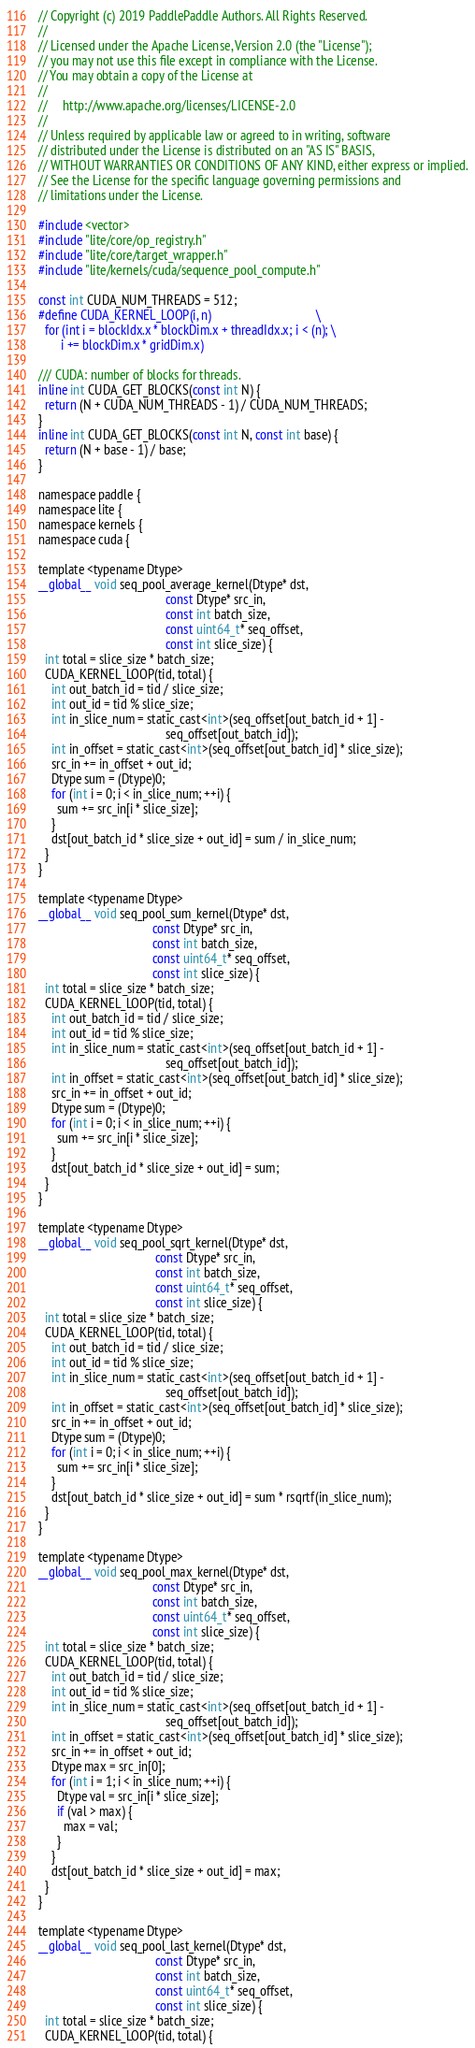<code> <loc_0><loc_0><loc_500><loc_500><_Cuda_>// Copyright (c) 2019 PaddlePaddle Authors. All Rights Reserved.
//
// Licensed under the Apache License, Version 2.0 (the "License");
// you may not use this file except in compliance with the License.
// You may obtain a copy of the License at
//
//     http://www.apache.org/licenses/LICENSE-2.0
//
// Unless required by applicable law or agreed to in writing, software
// distributed under the License is distributed on an "AS IS" BASIS,
// WITHOUT WARRANTIES OR CONDITIONS OF ANY KIND, either express or implied.
// See the License for the specific language governing permissions and
// limitations under the License.

#include <vector>
#include "lite/core/op_registry.h"
#include "lite/core/target_wrapper.h"
#include "lite/kernels/cuda/sequence_pool_compute.h"

const int CUDA_NUM_THREADS = 512;
#define CUDA_KERNEL_LOOP(i, n)                                 \
  for (int i = blockIdx.x * blockDim.x + threadIdx.x; i < (n); \
       i += blockDim.x * gridDim.x)

/// CUDA: number of blocks for threads.
inline int CUDA_GET_BLOCKS(const int N) {
  return (N + CUDA_NUM_THREADS - 1) / CUDA_NUM_THREADS;
}
inline int CUDA_GET_BLOCKS(const int N, const int base) {
  return (N + base - 1) / base;
}

namespace paddle {
namespace lite {
namespace kernels {
namespace cuda {

template <typename Dtype>
__global__ void seq_pool_average_kernel(Dtype* dst,
                                        const Dtype* src_in,
                                        const int batch_size,
                                        const uint64_t* seq_offset,
                                        const int slice_size) {
  int total = slice_size * batch_size;
  CUDA_KERNEL_LOOP(tid, total) {
    int out_batch_id = tid / slice_size;
    int out_id = tid % slice_size;
    int in_slice_num = static_cast<int>(seq_offset[out_batch_id + 1] -
                                        seq_offset[out_batch_id]);
    int in_offset = static_cast<int>(seq_offset[out_batch_id] * slice_size);
    src_in += in_offset + out_id;
    Dtype sum = (Dtype)0;
    for (int i = 0; i < in_slice_num; ++i) {
      sum += src_in[i * slice_size];
    }
    dst[out_batch_id * slice_size + out_id] = sum / in_slice_num;
  }
}

template <typename Dtype>
__global__ void seq_pool_sum_kernel(Dtype* dst,
                                    const Dtype* src_in,
                                    const int batch_size,
                                    const uint64_t* seq_offset,
                                    const int slice_size) {
  int total = slice_size * batch_size;
  CUDA_KERNEL_LOOP(tid, total) {
    int out_batch_id = tid / slice_size;
    int out_id = tid % slice_size;
    int in_slice_num = static_cast<int>(seq_offset[out_batch_id + 1] -
                                        seq_offset[out_batch_id]);
    int in_offset = static_cast<int>(seq_offset[out_batch_id] * slice_size);
    src_in += in_offset + out_id;
    Dtype sum = (Dtype)0;
    for (int i = 0; i < in_slice_num; ++i) {
      sum += src_in[i * slice_size];
    }
    dst[out_batch_id * slice_size + out_id] = sum;
  }
}

template <typename Dtype>
__global__ void seq_pool_sqrt_kernel(Dtype* dst,
                                     const Dtype* src_in,
                                     const int batch_size,
                                     const uint64_t* seq_offset,
                                     const int slice_size) {
  int total = slice_size * batch_size;
  CUDA_KERNEL_LOOP(tid, total) {
    int out_batch_id = tid / slice_size;
    int out_id = tid % slice_size;
    int in_slice_num = static_cast<int>(seq_offset[out_batch_id + 1] -
                                        seq_offset[out_batch_id]);
    int in_offset = static_cast<int>(seq_offset[out_batch_id] * slice_size);
    src_in += in_offset + out_id;
    Dtype sum = (Dtype)0;
    for (int i = 0; i < in_slice_num; ++i) {
      sum += src_in[i * slice_size];
    }
    dst[out_batch_id * slice_size + out_id] = sum * rsqrtf(in_slice_num);
  }
}

template <typename Dtype>
__global__ void seq_pool_max_kernel(Dtype* dst,
                                    const Dtype* src_in,
                                    const int batch_size,
                                    const uint64_t* seq_offset,
                                    const int slice_size) {
  int total = slice_size * batch_size;
  CUDA_KERNEL_LOOP(tid, total) {
    int out_batch_id = tid / slice_size;
    int out_id = tid % slice_size;
    int in_slice_num = static_cast<int>(seq_offset[out_batch_id + 1] -
                                        seq_offset[out_batch_id]);
    int in_offset = static_cast<int>(seq_offset[out_batch_id] * slice_size);
    src_in += in_offset + out_id;
    Dtype max = src_in[0];
    for (int i = 1; i < in_slice_num; ++i) {
      Dtype val = src_in[i * slice_size];
      if (val > max) {
        max = val;
      }
    }
    dst[out_batch_id * slice_size + out_id] = max;
  }
}

template <typename Dtype>
__global__ void seq_pool_last_kernel(Dtype* dst,
                                     const Dtype* src_in,
                                     const int batch_size,
                                     const uint64_t* seq_offset,
                                     const int slice_size) {
  int total = slice_size * batch_size;
  CUDA_KERNEL_LOOP(tid, total) {</code> 